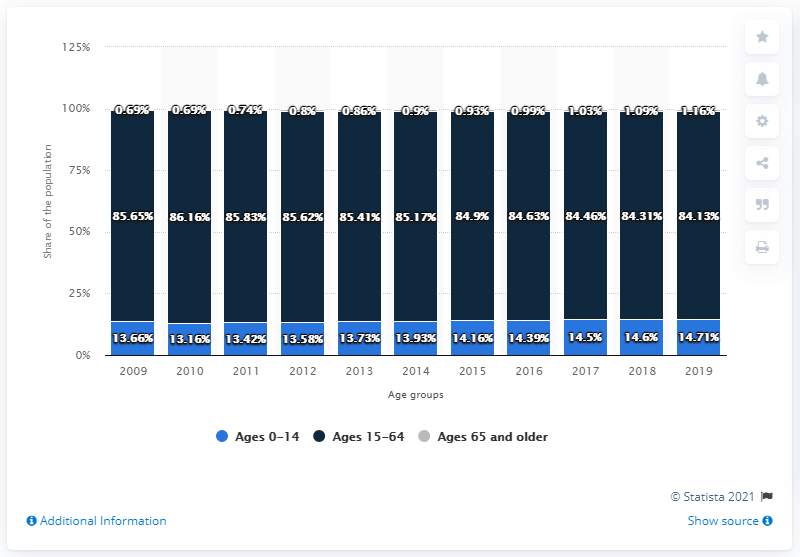Mention a couple of crucial points in this snapshot. In 2010, the dark blue bar had the highest value. In 2010, the age group 0-14 had the smallest percentage of blue bars out of all the other years. 